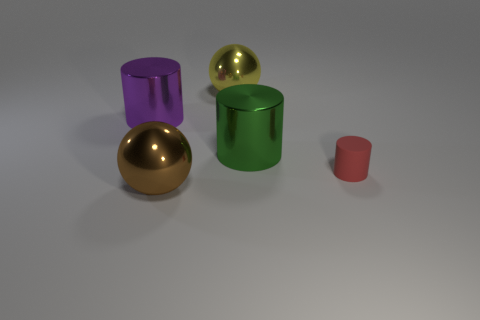Is there any other thing that has the same color as the tiny thing?
Ensure brevity in your answer.  No. Are there more large green cylinders that are in front of the large green shiny cylinder than large red shiny balls?
Your answer should be very brief. No. Do the green shiny object and the brown thing have the same size?
Ensure brevity in your answer.  Yes. There is a small object that is the same shape as the large green thing; what is it made of?
Your answer should be compact. Rubber. Is there any other thing that has the same material as the tiny cylinder?
Make the answer very short. No. How many green things are either cylinders or big cylinders?
Give a very brief answer. 1. There is a large cylinder that is on the right side of the big purple cylinder; what is it made of?
Ensure brevity in your answer.  Metal. Are there more large purple objects than metal cylinders?
Give a very brief answer. No. Does the thing in front of the small rubber object have the same shape as the yellow shiny object?
Your response must be concise. Yes. What number of big shiny objects are both left of the big brown object and right of the yellow shiny thing?
Provide a short and direct response. 0. 